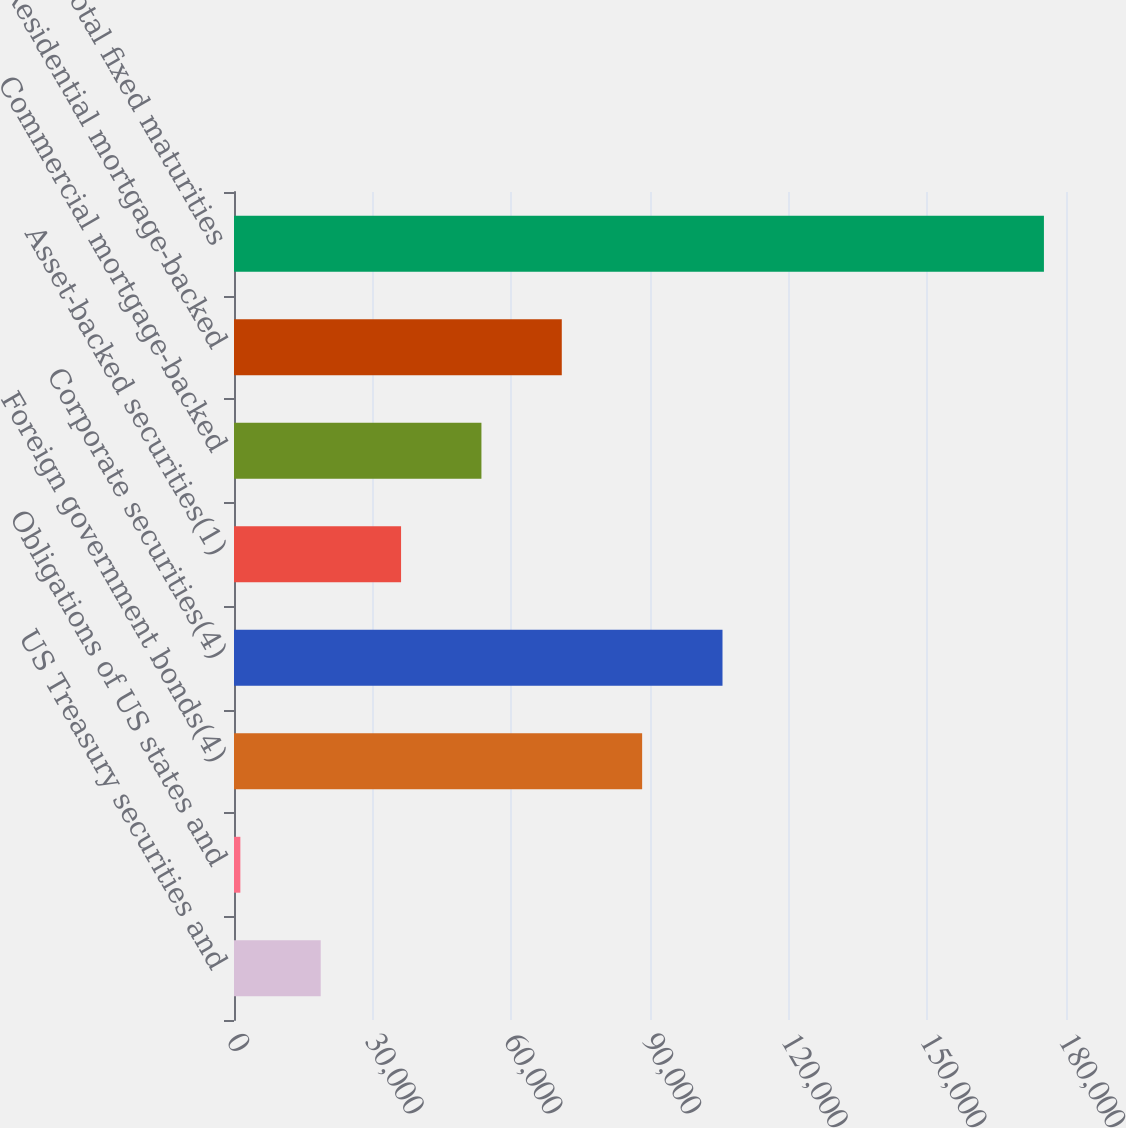Convert chart to OTSL. <chart><loc_0><loc_0><loc_500><loc_500><bar_chart><fcel>US Treasury securities and<fcel>Obligations of US states and<fcel>Foreign government bonds(4)<fcel>Corporate securities(4)<fcel>Asset-backed securities(1)<fcel>Commercial mortgage-backed<fcel>Residential mortgage-backed<fcel>Total fixed maturities<nl><fcel>18760<fcel>1375<fcel>88300<fcel>105685<fcel>36145<fcel>53530<fcel>70915<fcel>175225<nl></chart> 